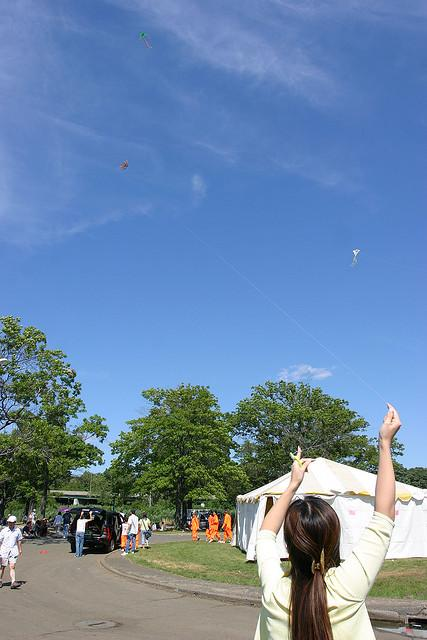What makes this a good day for flying kites?

Choices:
A) humid
B) cold
C) cloudy
D) clear skies clear skies 